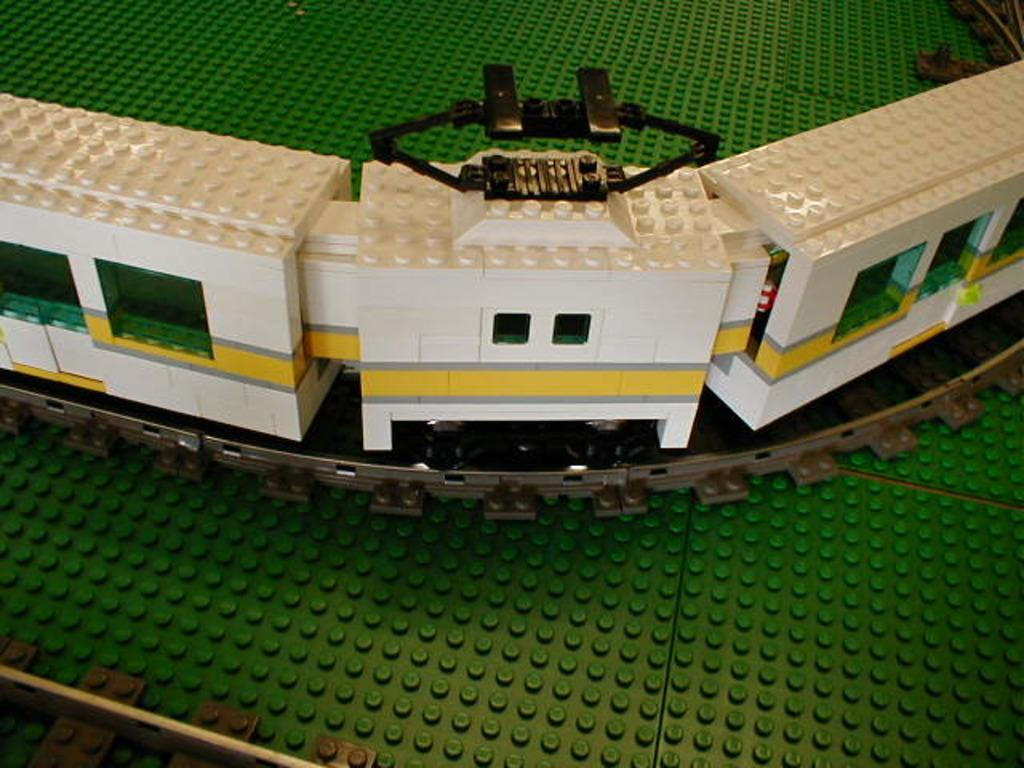What type of train is depicted in the image? There is a white train in the image. What material is the train made of? The train is made up of lego bricks. Is the train on a specific path in the image? Yes, the train is on a track. What color is the surface beneath the train? There is a green surface in the image. What invention is being demonstrated on the green surface in the image? There is no invention being demonstrated in the image; it simply shows a white train made of lego bricks on a track. 